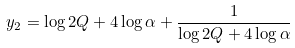<formula> <loc_0><loc_0><loc_500><loc_500>y _ { 2 } = \log 2 Q + 4 \log \alpha + \frac { 1 } { \log 2 Q + 4 \log \alpha }</formula> 